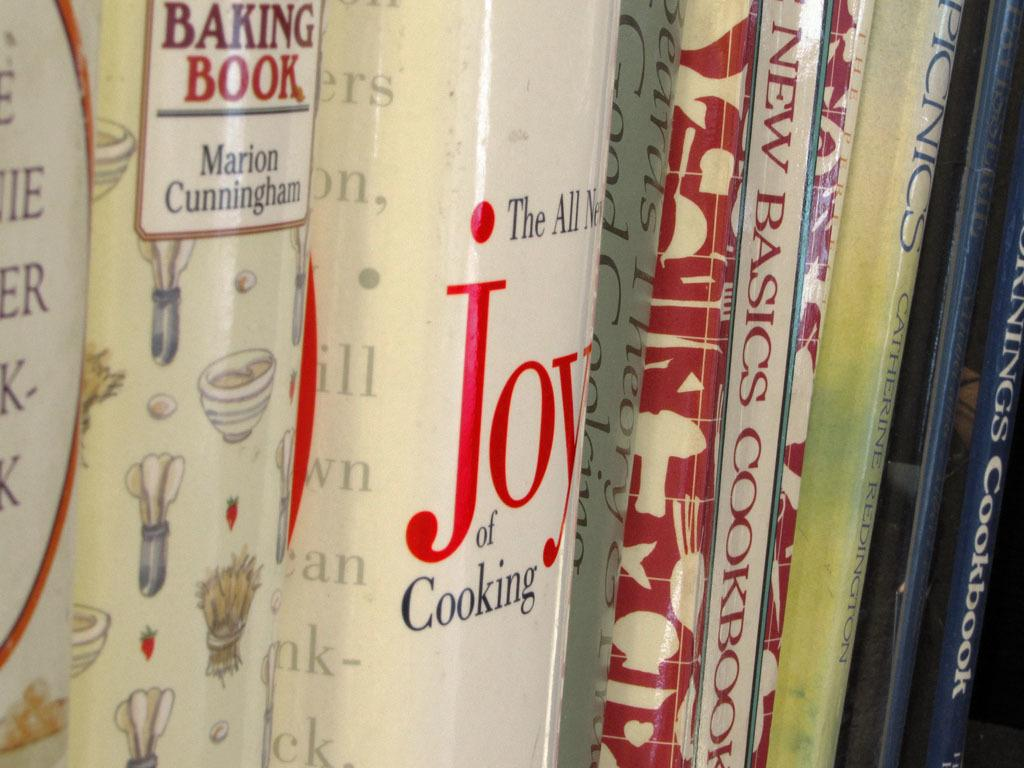Provide a one-sentence caption for the provided image. Several books are lined up, including the Joy of Cooking and a Baking Book. 